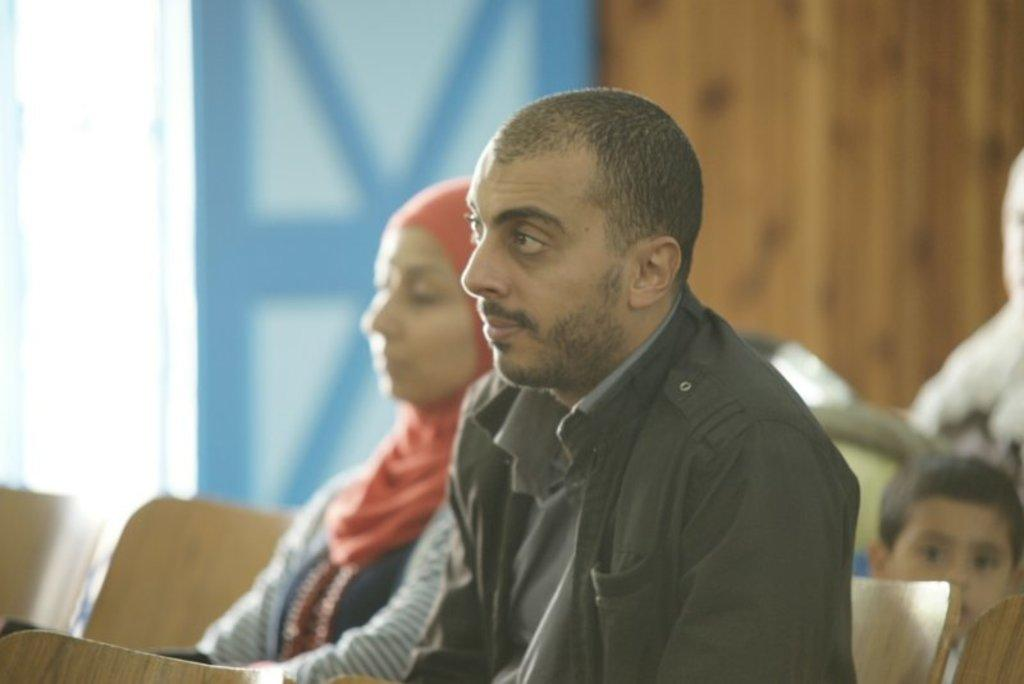What are the people in the image doing? The persons in the image are sitting on chairs. What can be seen in the background of the image? There is a wall and a board in the background of the image. What type of mist is visible in the image? There is no mist present in the image. What is the purpose of the notebook in the image? There is no notebook present in the image. 